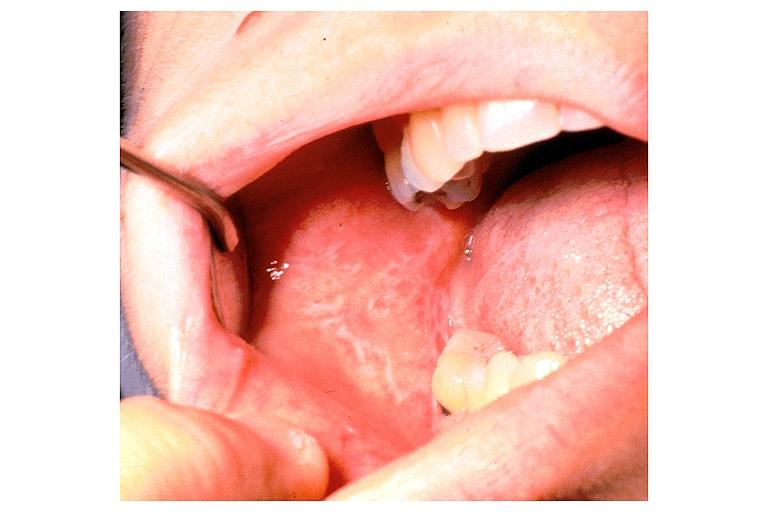where is this?
Answer the question using a single word or phrase. Oral 